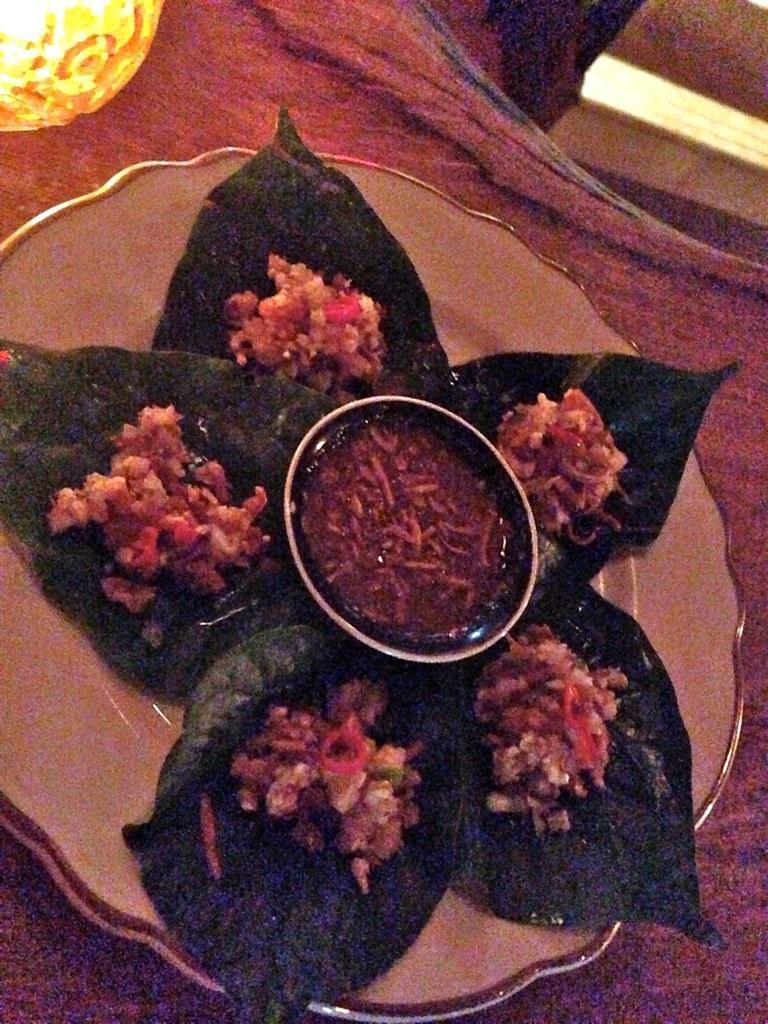In one or two sentences, can you explain what this image depicts? In this image we can see a plate and there are leaves and some food placed on the plate. At the bottom there is a cloth and a light. 